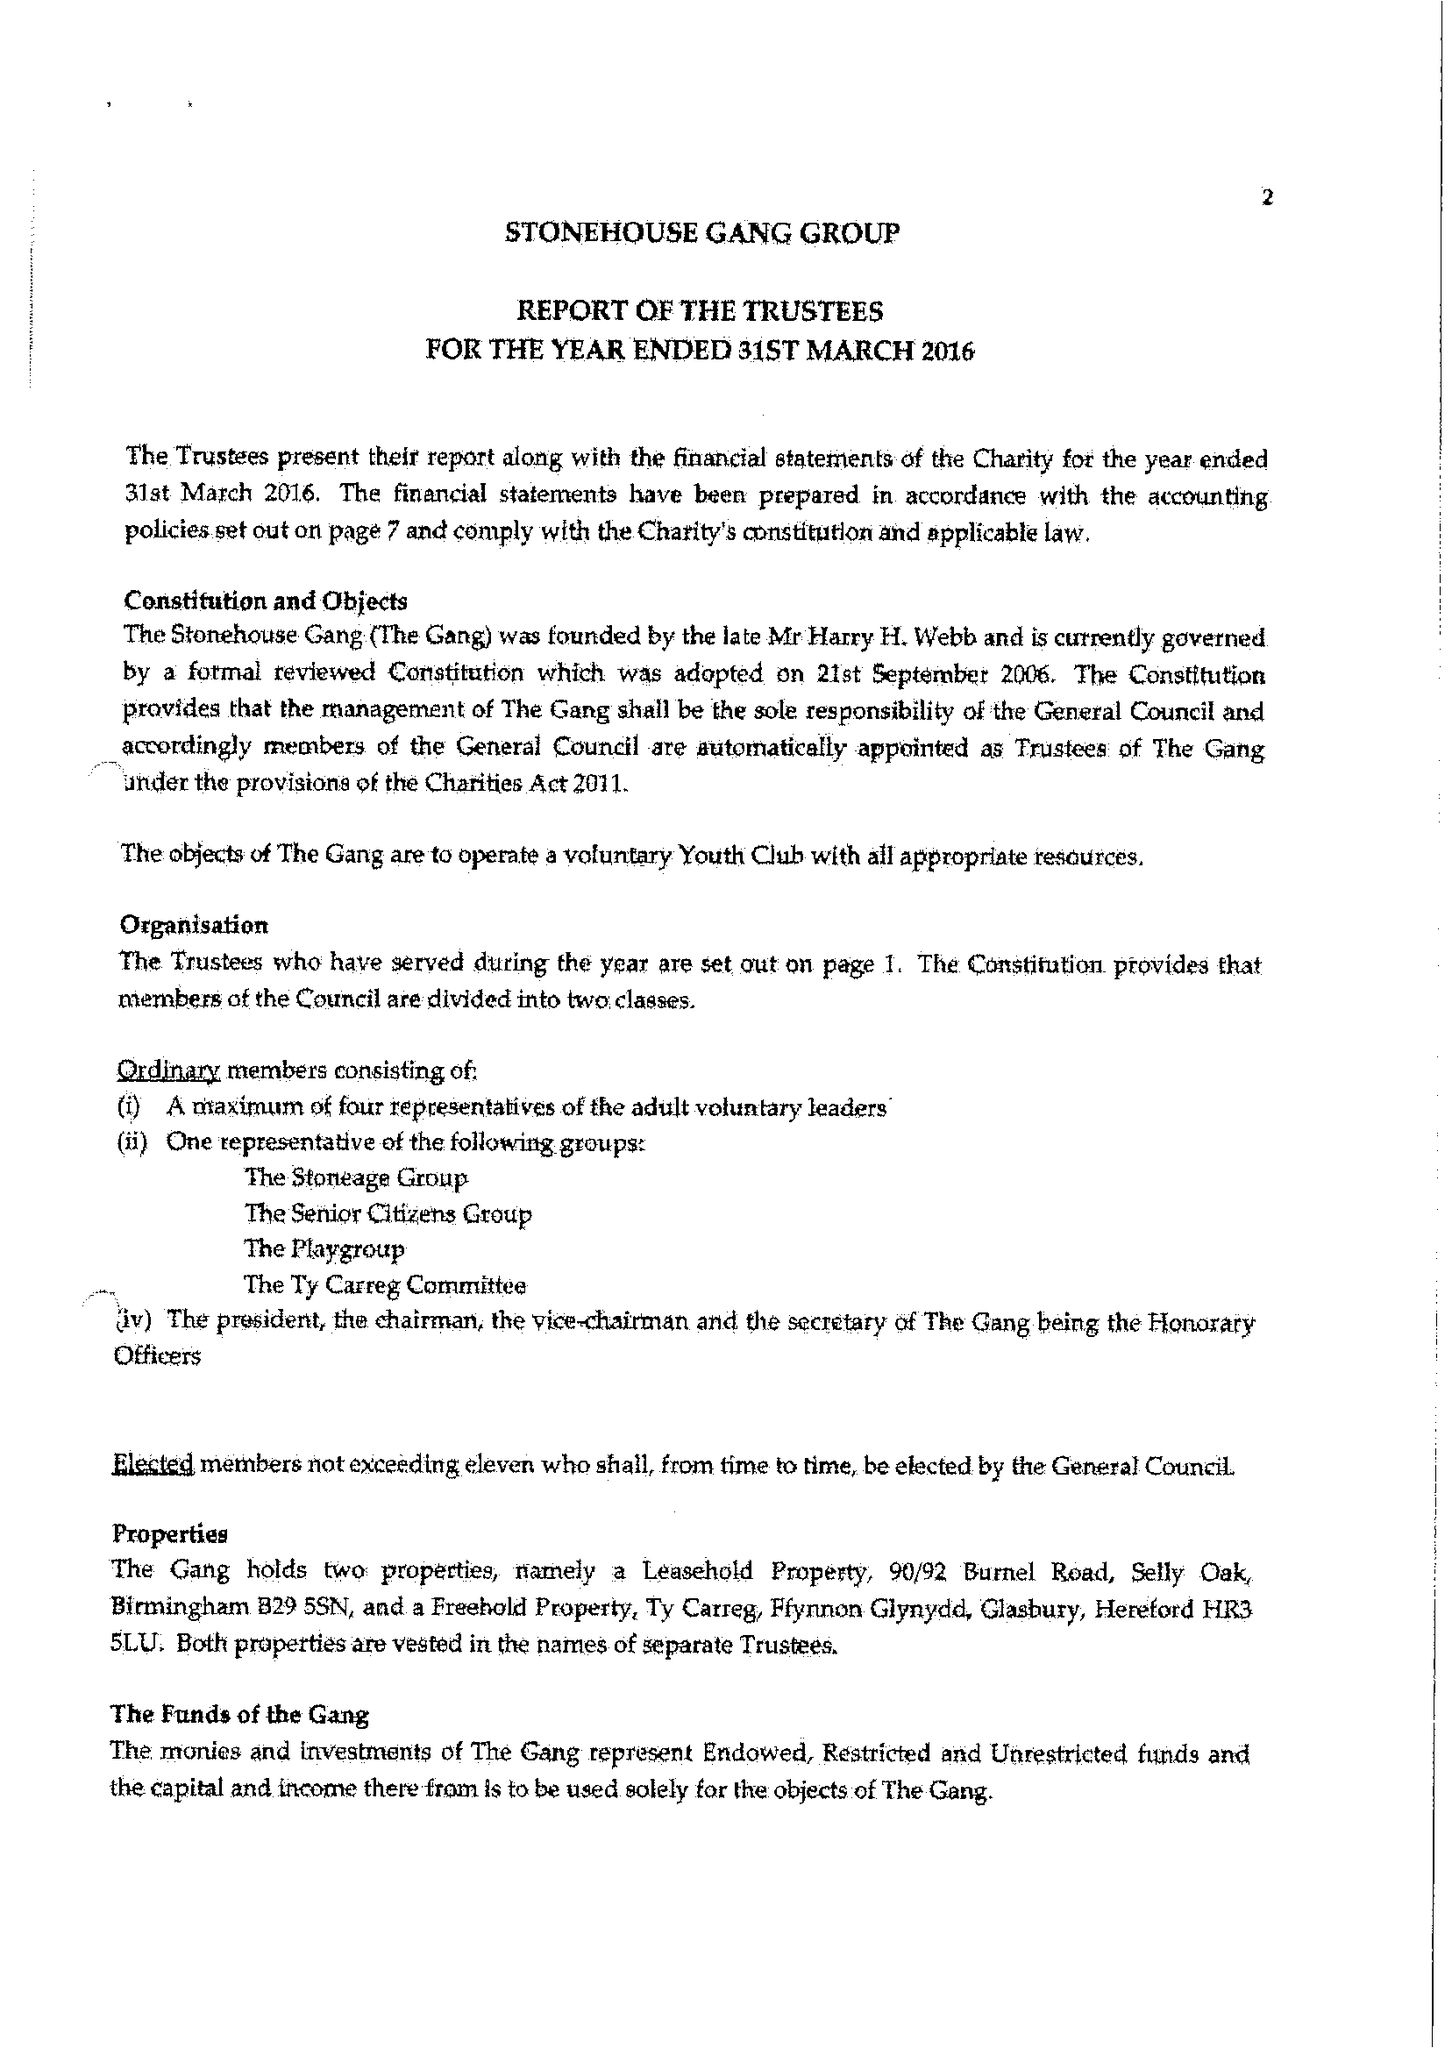What is the value for the address__street_line?
Answer the question using a single word or phrase. None 